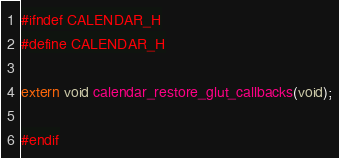<code> <loc_0><loc_0><loc_500><loc_500><_C_>#ifndef CALENDAR_H
#define CALENDAR_H

extern void calendar_restore_glut_callbacks(void);

#endif
</code> 